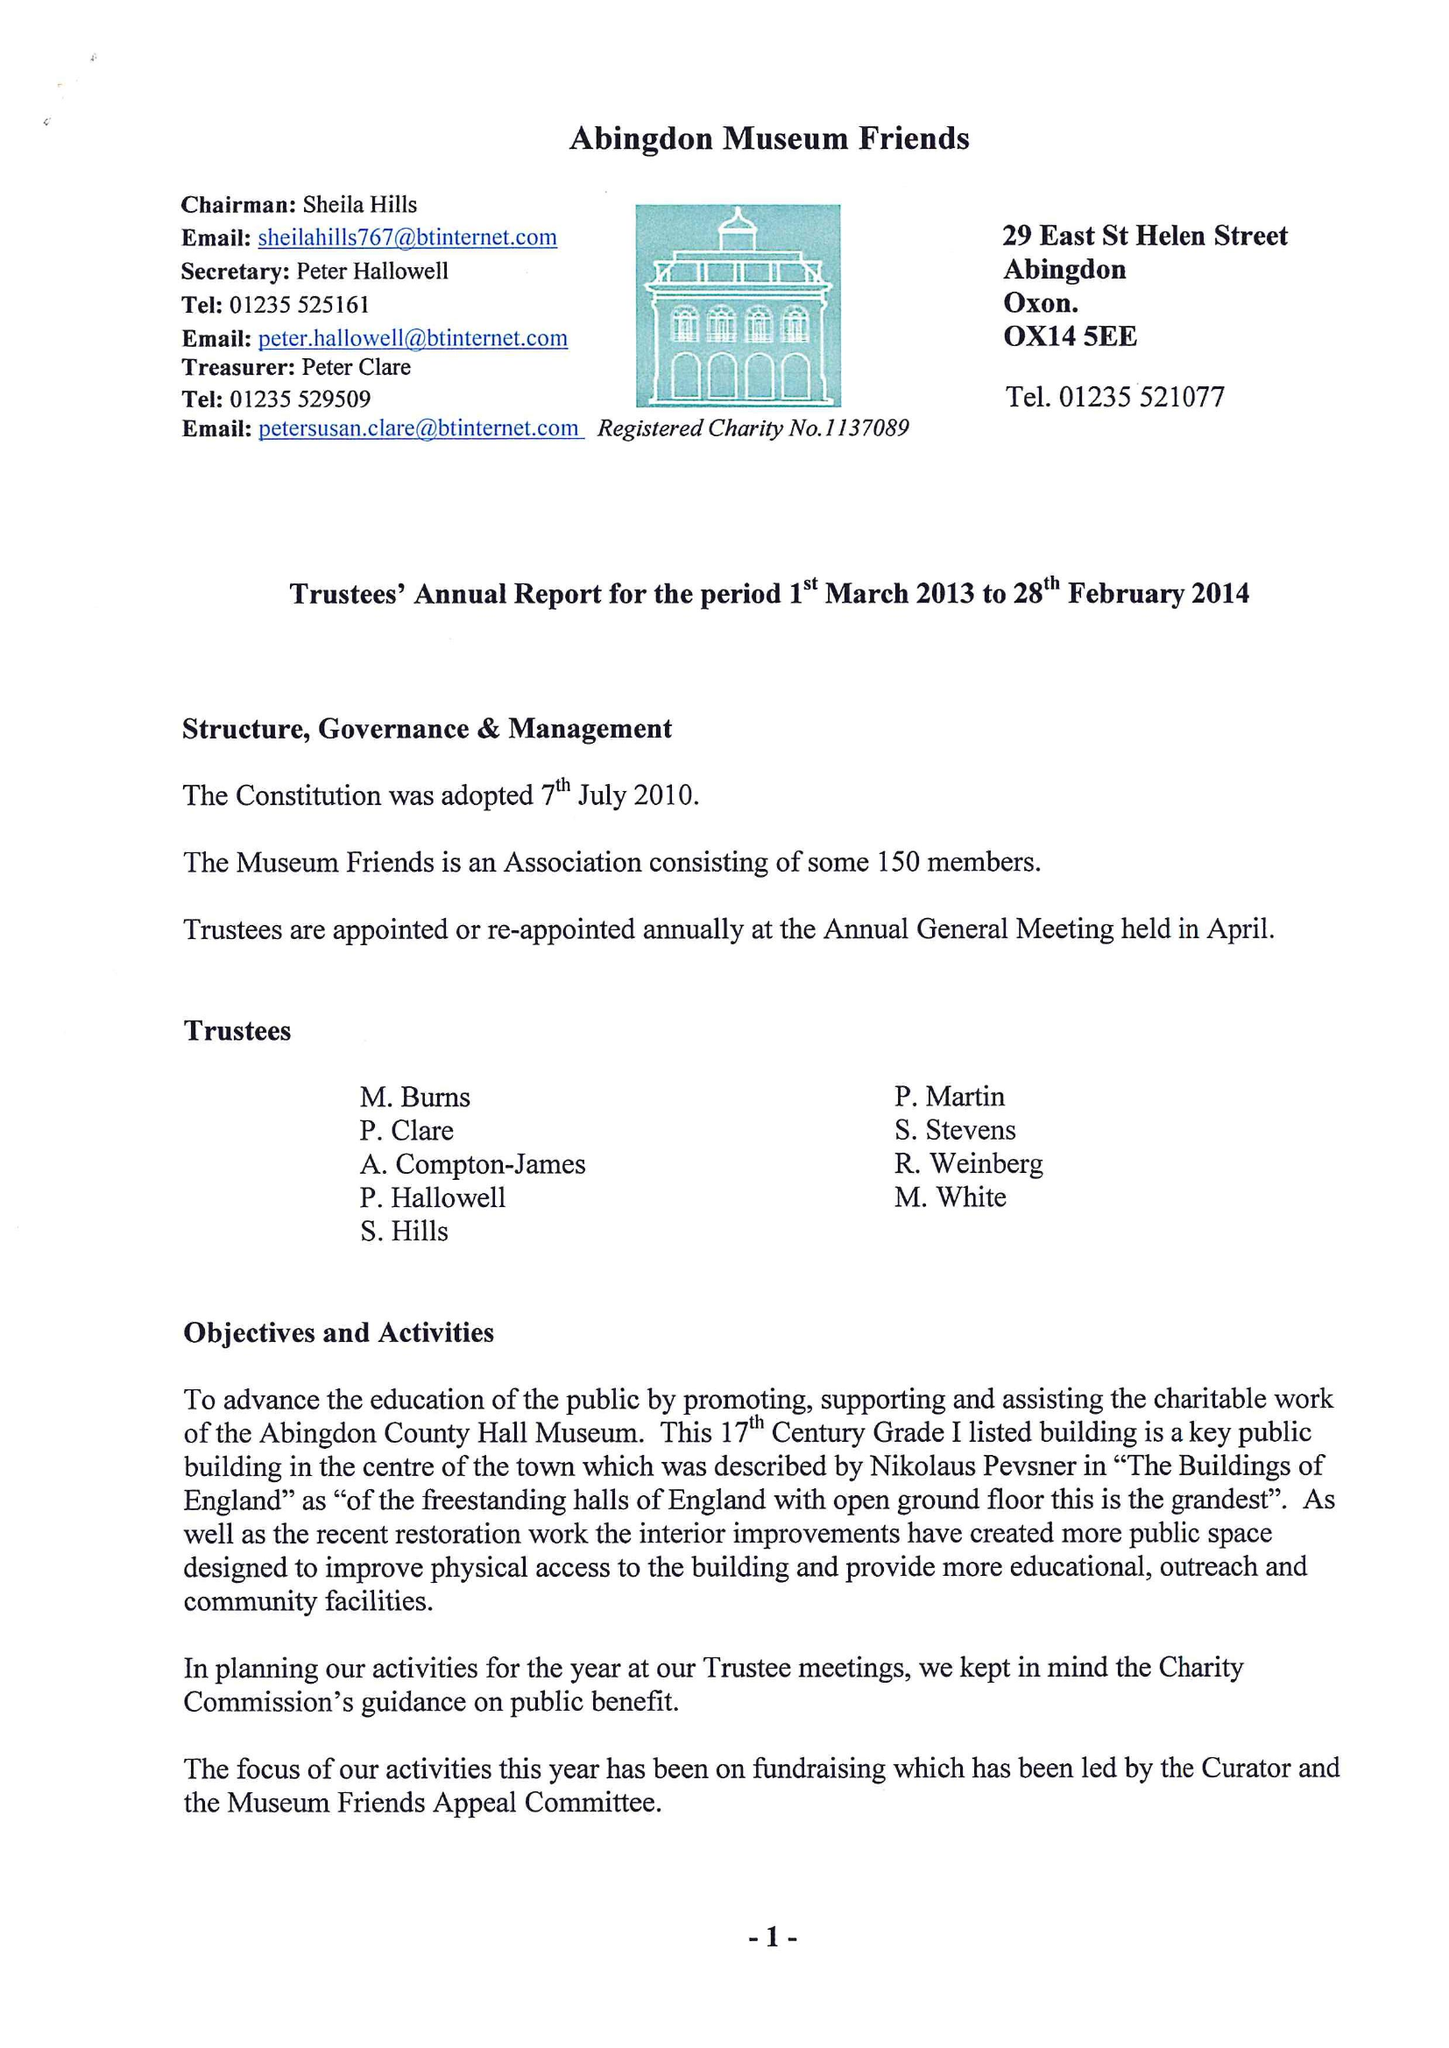What is the value for the charity_name?
Answer the question using a single word or phrase. Abingdon Museum Friends 